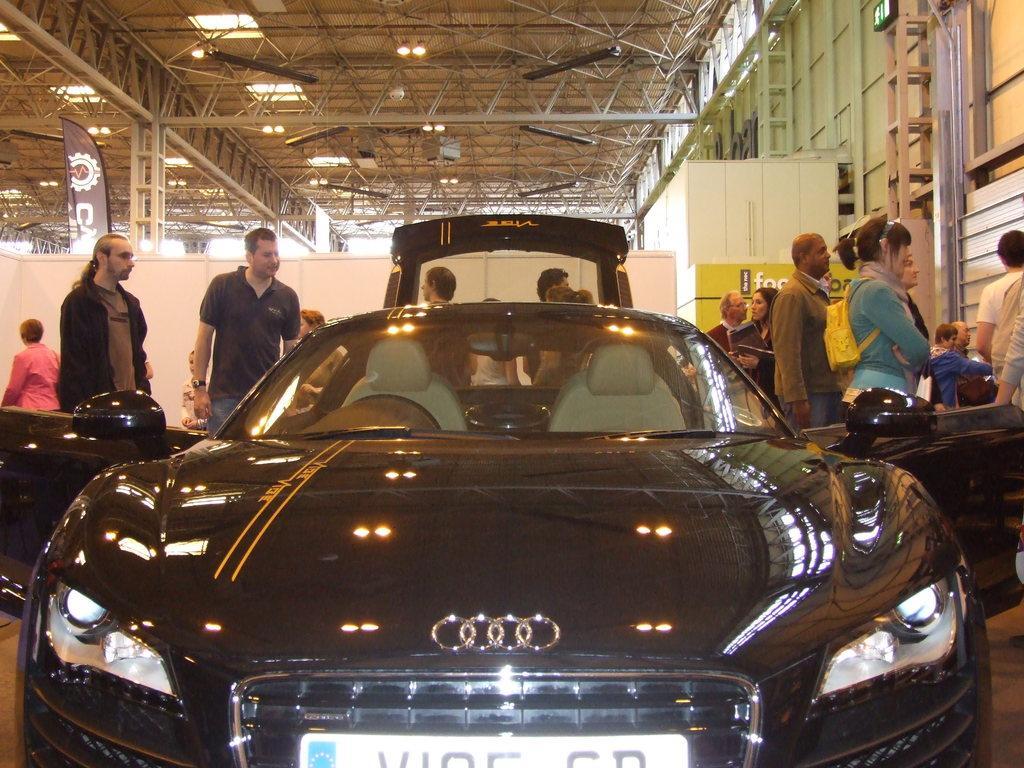Please provide a concise description of this image. In this image I can see a car which is black in color on the ground. In the background I can see few persons standing, white colored wall, the ceiling, few lights to the ceiling and few other objects. 